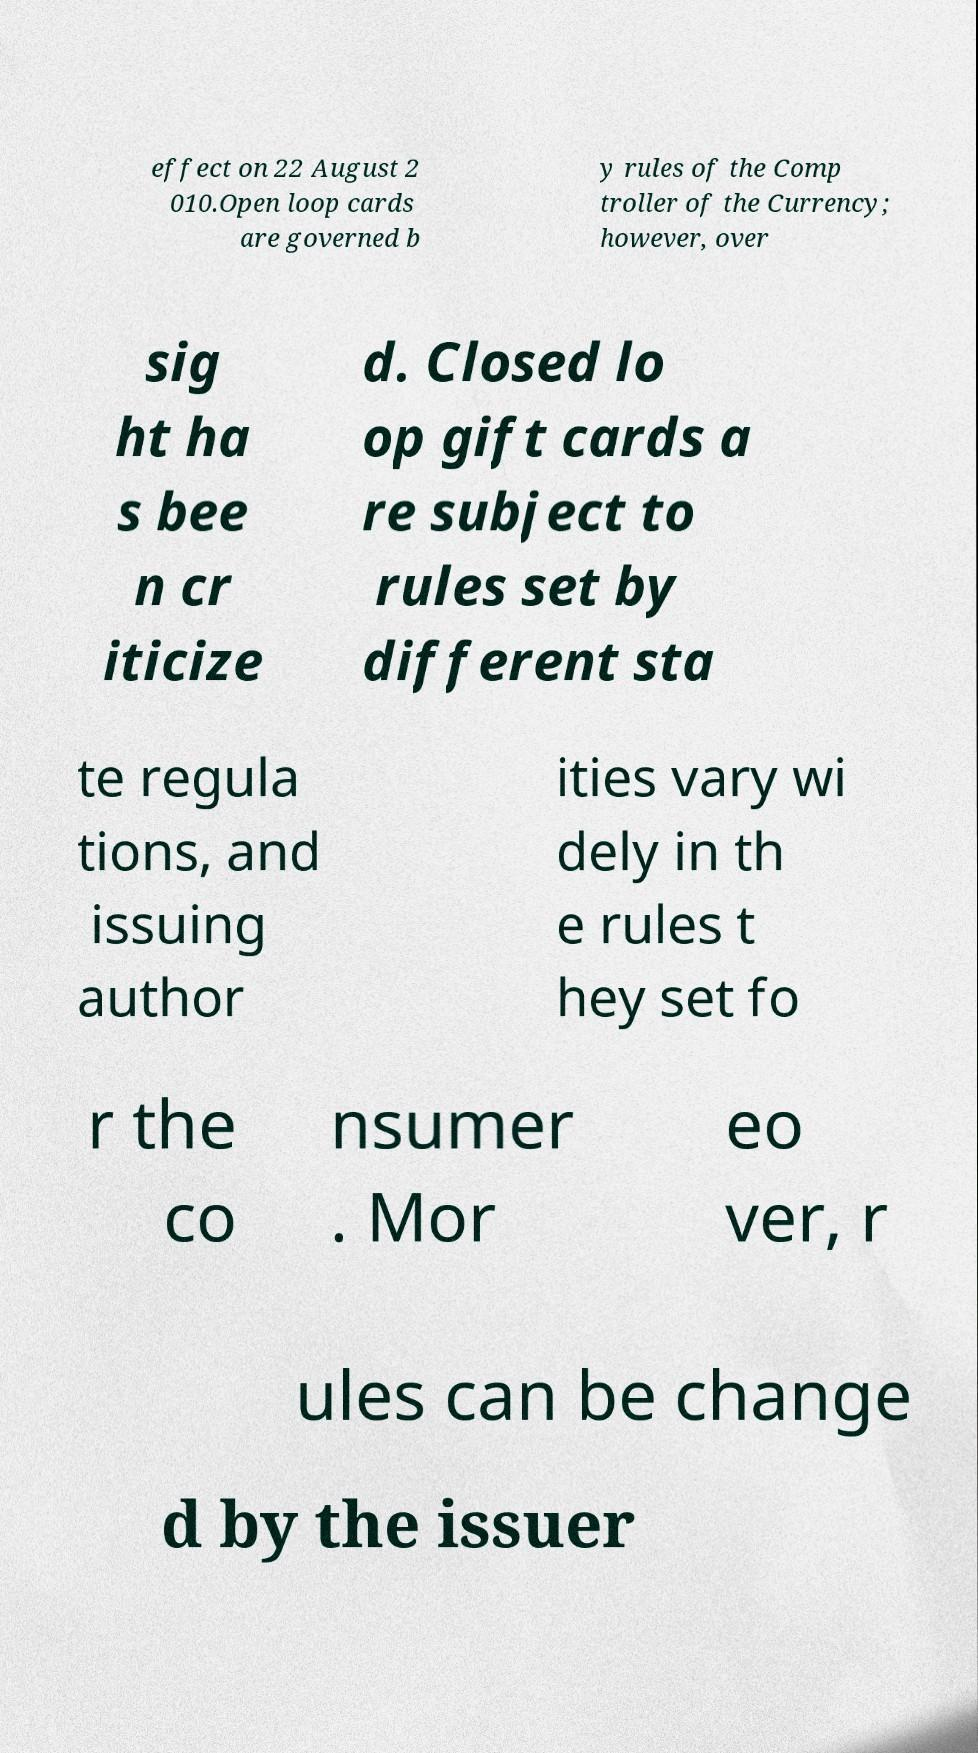Could you assist in decoding the text presented in this image and type it out clearly? effect on 22 August 2 010.Open loop cards are governed b y rules of the Comp troller of the Currency; however, over sig ht ha s bee n cr iticize d. Closed lo op gift cards a re subject to rules set by different sta te regula tions, and issuing author ities vary wi dely in th e rules t hey set fo r the co nsumer . Mor eo ver, r ules can be change d by the issuer 